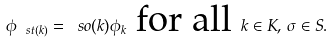Convert formula to latex. <formula><loc_0><loc_0><loc_500><loc_500>\phi _ { \ s t ( k ) } = \ s o ( k ) \phi _ { k } \text { for all } k \in K , \, \sigma \in S .</formula> 